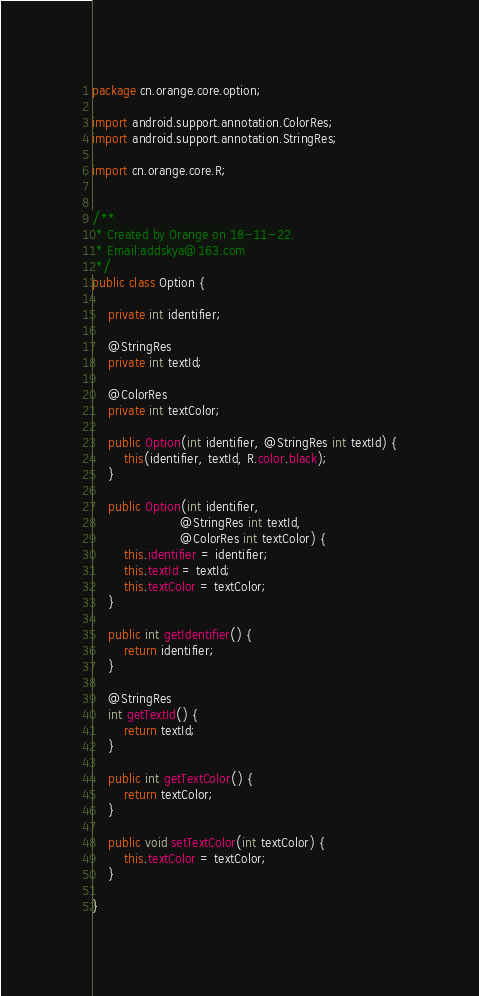Convert code to text. <code><loc_0><loc_0><loc_500><loc_500><_Java_>package cn.orange.core.option;

import android.support.annotation.ColorRes;
import android.support.annotation.StringRes;

import cn.orange.core.R;


/**
 * Created by Orange on 18-11-22.
 * Email:addskya@163.com
 */
public class Option {

    private int identifier;

    @StringRes
    private int textId;

    @ColorRes
    private int textColor;

    public Option(int identifier, @StringRes int textId) {
        this(identifier, textId, R.color.black);
    }

    public Option(int identifier,
                      @StringRes int textId,
                      @ColorRes int textColor) {
        this.identifier = identifier;
        this.textId = textId;
        this.textColor = textColor;
    }

    public int getIdentifier() {
        return identifier;
    }

    @StringRes
    int getTextId() {
        return textId;
    }

    public int getTextColor() {
        return textColor;
    }

    public void setTextColor(int textColor) {
        this.textColor = textColor;
    }

}
</code> 